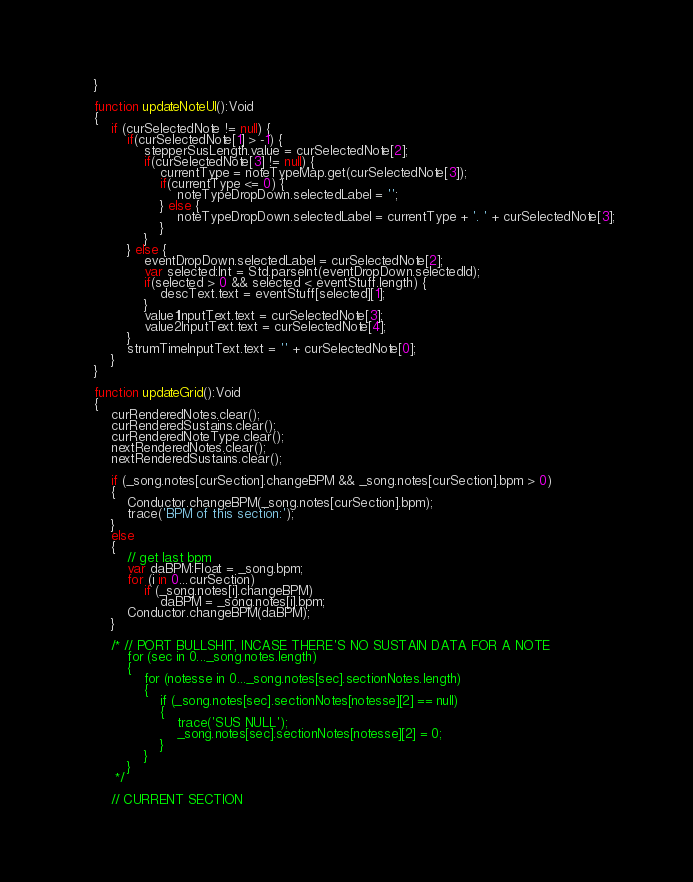<code> <loc_0><loc_0><loc_500><loc_500><_Haxe_>	}

	function updateNoteUI():Void
	{
		if (curSelectedNote != null) {
			if(curSelectedNote[1] > -1) {
				stepperSusLength.value = curSelectedNote[2];
				if(curSelectedNote[3] != null) {
					currentType = noteTypeMap.get(curSelectedNote[3]);
					if(currentType <= 0) {
						noteTypeDropDown.selectedLabel = '';
					} else {
						noteTypeDropDown.selectedLabel = currentType + '. ' + curSelectedNote[3];
					}
				}
			} else {
				eventDropDown.selectedLabel = curSelectedNote[2];
				var selected:Int = Std.parseInt(eventDropDown.selectedId);
				if(selected > 0 && selected < eventStuff.length) {
					descText.text = eventStuff[selected][1];
				}
				value1InputText.text = curSelectedNote[3];
				value2InputText.text = curSelectedNote[4];
			}
			strumTimeInputText.text = '' + curSelectedNote[0];
		}
	}

	function updateGrid():Void
	{
		curRenderedNotes.clear();
		curRenderedSustains.clear();
		curRenderedNoteType.clear();
		nextRenderedNotes.clear();
		nextRenderedSustains.clear();

		if (_song.notes[curSection].changeBPM && _song.notes[curSection].bpm > 0)
		{
			Conductor.changeBPM(_song.notes[curSection].bpm);
			trace('BPM of this section:');
		}
		else
		{
			// get last bpm
			var daBPM:Float = _song.bpm;
			for (i in 0...curSection)
				if (_song.notes[i].changeBPM)
					daBPM = _song.notes[i].bpm;
			Conductor.changeBPM(daBPM);
		}

		/* // PORT BULLSHIT, INCASE THERE'S NO SUSTAIN DATA FOR A NOTE
			for (sec in 0..._song.notes.length)
			{
				for (notesse in 0..._song.notes[sec].sectionNotes.length)
				{
					if (_song.notes[sec].sectionNotes[notesse][2] == null)
					{
						trace('SUS NULL');
						_song.notes[sec].sectionNotes[notesse][2] = 0;
					}
				}
			}
		 */

		// CURRENT SECTION</code> 